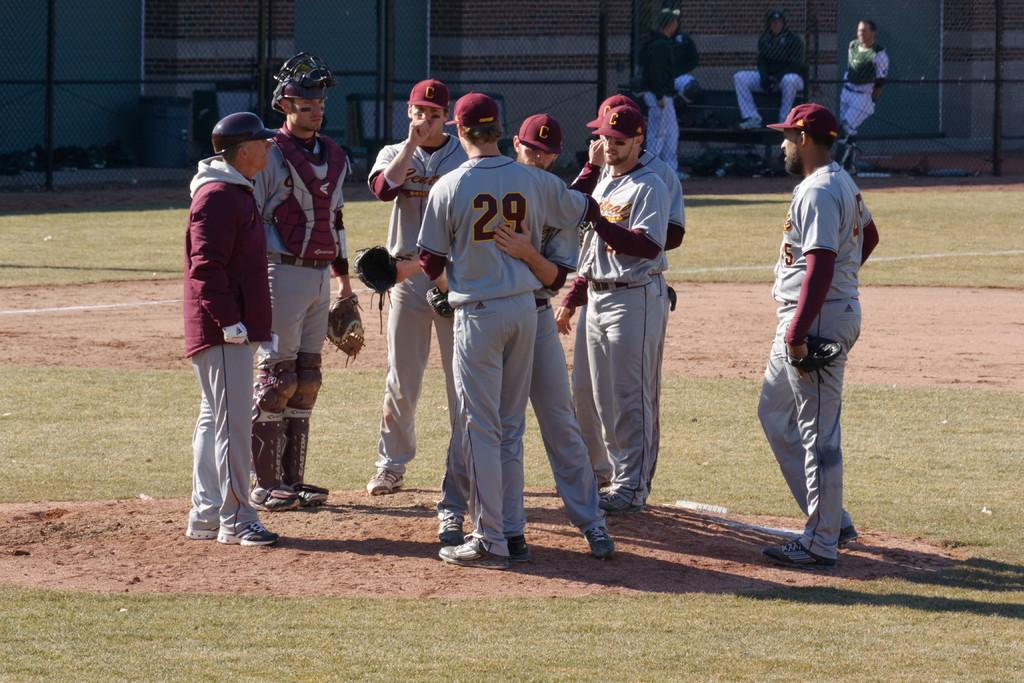<image>
Write a terse but informative summary of the picture. Group of baseball players standing in centerfield on a nice sunny day, one of the players has the number 29 on the back of his shirt. 